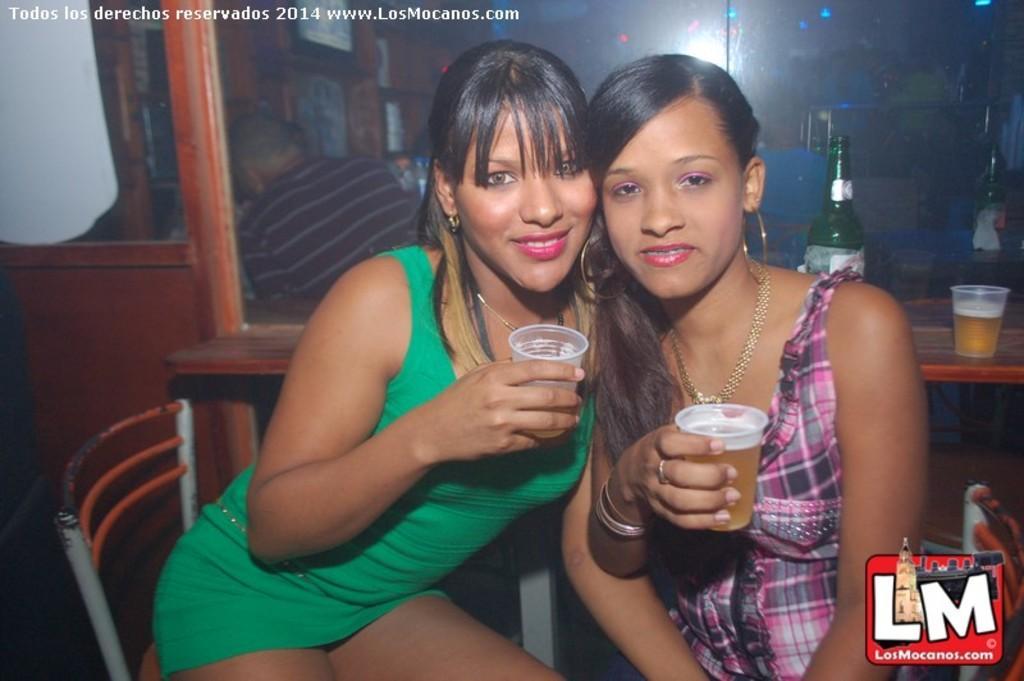Please provide a concise description of this image. In the image we can see two women are sitting and holding glasses and smiling. Behind them there is a table, on the table there are some bottles and glasses. Top of the image there is glass. 